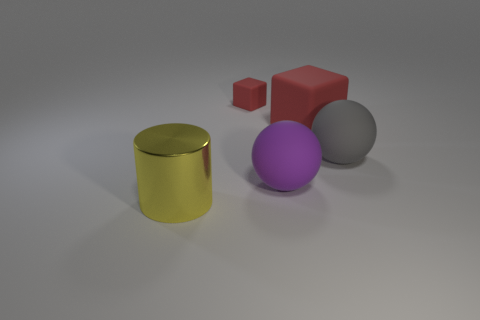Can you describe the size comparison between the purple object and the others? The purple sphere is larger than the red cube and the gray sphere, but smaller than the yellow cylinder. Its size provides a point of reference for comparing the other objects in the image. 